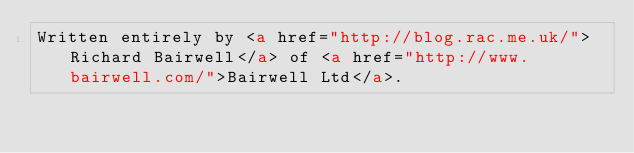Convert code to text. <code><loc_0><loc_0><loc_500><loc_500><_HTML_>Written entirely by <a href="http://blog.rac.me.uk/">Richard Bairwell</a> of <a href="http://www.bairwell.com/">Bairwell Ltd</a>.</code> 